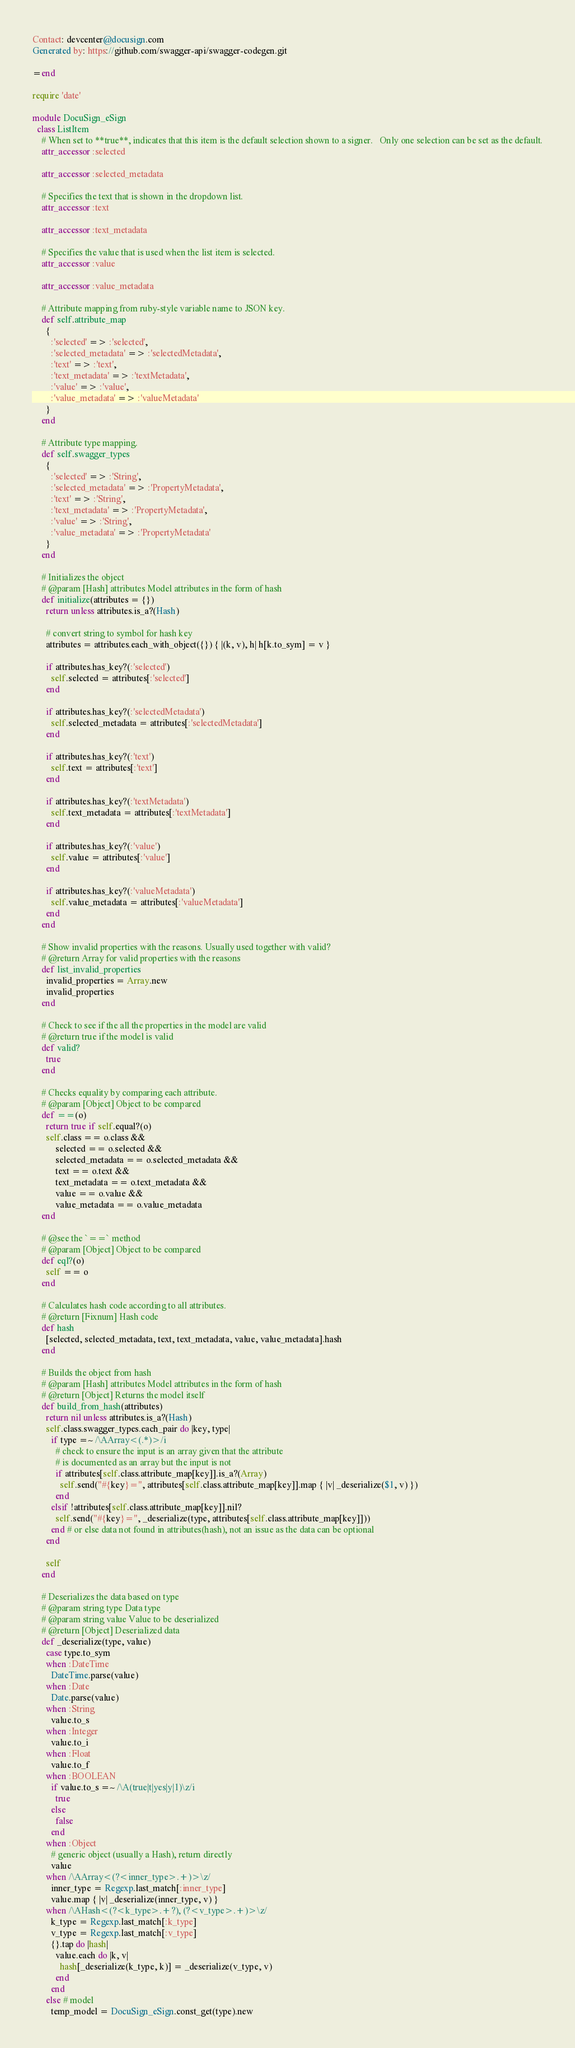Convert code to text. <code><loc_0><loc_0><loc_500><loc_500><_Ruby_>Contact: devcenter@docusign.com
Generated by: https://github.com/swagger-api/swagger-codegen.git

=end

require 'date'

module DocuSign_eSign
  class ListItem
    # When set to **true**, indicates that this item is the default selection shown to a signer.   Only one selection can be set as the default.
    attr_accessor :selected

    attr_accessor :selected_metadata

    # Specifies the text that is shown in the dropdown list. 
    attr_accessor :text

    attr_accessor :text_metadata

    # Specifies the value that is used when the list item is selected.
    attr_accessor :value

    attr_accessor :value_metadata

    # Attribute mapping from ruby-style variable name to JSON key.
    def self.attribute_map
      {
        :'selected' => :'selected',
        :'selected_metadata' => :'selectedMetadata',
        :'text' => :'text',
        :'text_metadata' => :'textMetadata',
        :'value' => :'value',
        :'value_metadata' => :'valueMetadata'
      }
    end

    # Attribute type mapping.
    def self.swagger_types
      {
        :'selected' => :'String',
        :'selected_metadata' => :'PropertyMetadata',
        :'text' => :'String',
        :'text_metadata' => :'PropertyMetadata',
        :'value' => :'String',
        :'value_metadata' => :'PropertyMetadata'
      }
    end

    # Initializes the object
    # @param [Hash] attributes Model attributes in the form of hash
    def initialize(attributes = {})
      return unless attributes.is_a?(Hash)

      # convert string to symbol for hash key
      attributes = attributes.each_with_object({}) { |(k, v), h| h[k.to_sym] = v }

      if attributes.has_key?(:'selected')
        self.selected = attributes[:'selected']
      end

      if attributes.has_key?(:'selectedMetadata')
        self.selected_metadata = attributes[:'selectedMetadata']
      end

      if attributes.has_key?(:'text')
        self.text = attributes[:'text']
      end

      if attributes.has_key?(:'textMetadata')
        self.text_metadata = attributes[:'textMetadata']
      end

      if attributes.has_key?(:'value')
        self.value = attributes[:'value']
      end

      if attributes.has_key?(:'valueMetadata')
        self.value_metadata = attributes[:'valueMetadata']
      end
    end

    # Show invalid properties with the reasons. Usually used together with valid?
    # @return Array for valid properties with the reasons
    def list_invalid_properties
      invalid_properties = Array.new
      invalid_properties
    end

    # Check to see if the all the properties in the model are valid
    # @return true if the model is valid
    def valid?
      true
    end

    # Checks equality by comparing each attribute.
    # @param [Object] Object to be compared
    def ==(o)
      return true if self.equal?(o)
      self.class == o.class &&
          selected == o.selected &&
          selected_metadata == o.selected_metadata &&
          text == o.text &&
          text_metadata == o.text_metadata &&
          value == o.value &&
          value_metadata == o.value_metadata
    end

    # @see the `==` method
    # @param [Object] Object to be compared
    def eql?(o)
      self == o
    end

    # Calculates hash code according to all attributes.
    # @return [Fixnum] Hash code
    def hash
      [selected, selected_metadata, text, text_metadata, value, value_metadata].hash
    end

    # Builds the object from hash
    # @param [Hash] attributes Model attributes in the form of hash
    # @return [Object] Returns the model itself
    def build_from_hash(attributes)
      return nil unless attributes.is_a?(Hash)
      self.class.swagger_types.each_pair do |key, type|
        if type =~ /\AArray<(.*)>/i
          # check to ensure the input is an array given that the attribute
          # is documented as an array but the input is not
          if attributes[self.class.attribute_map[key]].is_a?(Array)
            self.send("#{key}=", attributes[self.class.attribute_map[key]].map { |v| _deserialize($1, v) })
          end
        elsif !attributes[self.class.attribute_map[key]].nil?
          self.send("#{key}=", _deserialize(type, attributes[self.class.attribute_map[key]]))
        end # or else data not found in attributes(hash), not an issue as the data can be optional
      end

      self
    end

    # Deserializes the data based on type
    # @param string type Data type
    # @param string value Value to be deserialized
    # @return [Object] Deserialized data
    def _deserialize(type, value)
      case type.to_sym
      when :DateTime
        DateTime.parse(value)
      when :Date
        Date.parse(value)
      when :String
        value.to_s
      when :Integer
        value.to_i
      when :Float
        value.to_f
      when :BOOLEAN
        if value.to_s =~ /\A(true|t|yes|y|1)\z/i
          true
        else
          false
        end
      when :Object
        # generic object (usually a Hash), return directly
        value
      when /\AArray<(?<inner_type>.+)>\z/
        inner_type = Regexp.last_match[:inner_type]
        value.map { |v| _deserialize(inner_type, v) }
      when /\AHash<(?<k_type>.+?), (?<v_type>.+)>\z/
        k_type = Regexp.last_match[:k_type]
        v_type = Regexp.last_match[:v_type]
        {}.tap do |hash|
          value.each do |k, v|
            hash[_deserialize(k_type, k)] = _deserialize(v_type, v)
          end
        end
      else # model
        temp_model = DocuSign_eSign.const_get(type).new</code> 